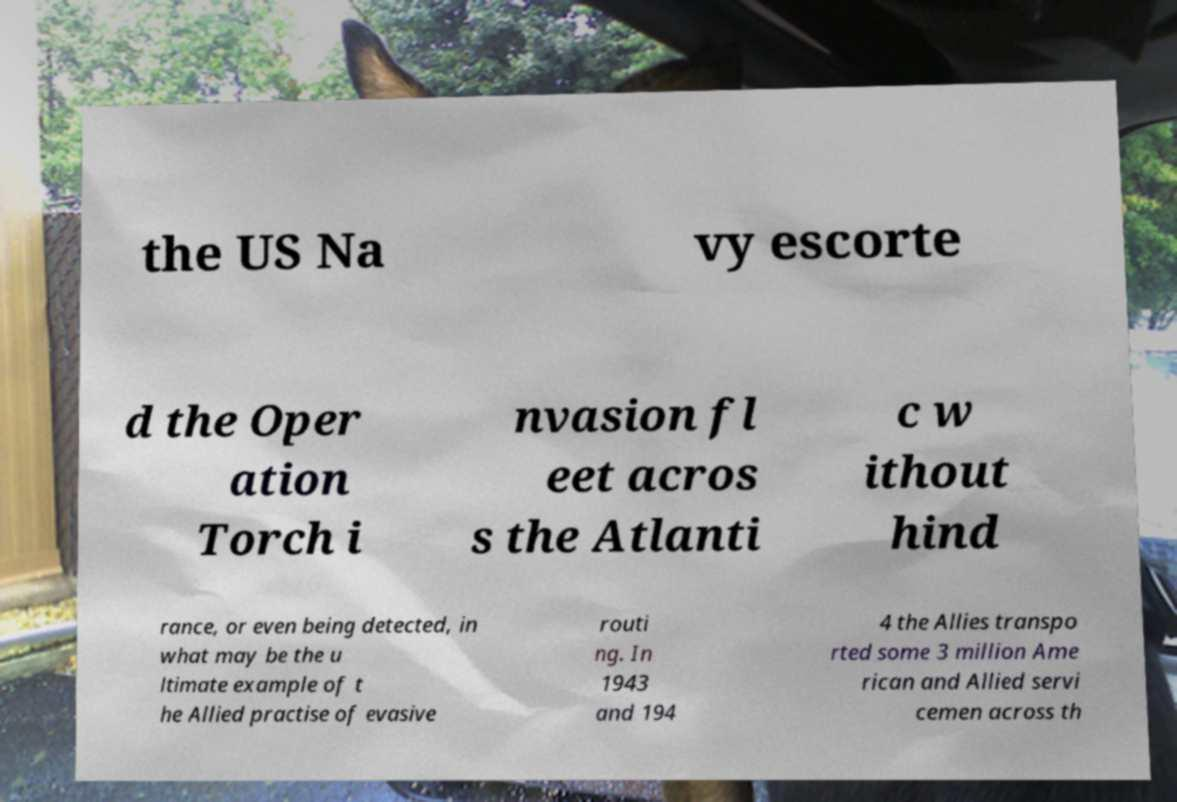There's text embedded in this image that I need extracted. Can you transcribe it verbatim? the US Na vy escorte d the Oper ation Torch i nvasion fl eet acros s the Atlanti c w ithout hind rance, or even being detected, in what may be the u ltimate example of t he Allied practise of evasive routi ng. In 1943 and 194 4 the Allies transpo rted some 3 million Ame rican and Allied servi cemen across th 